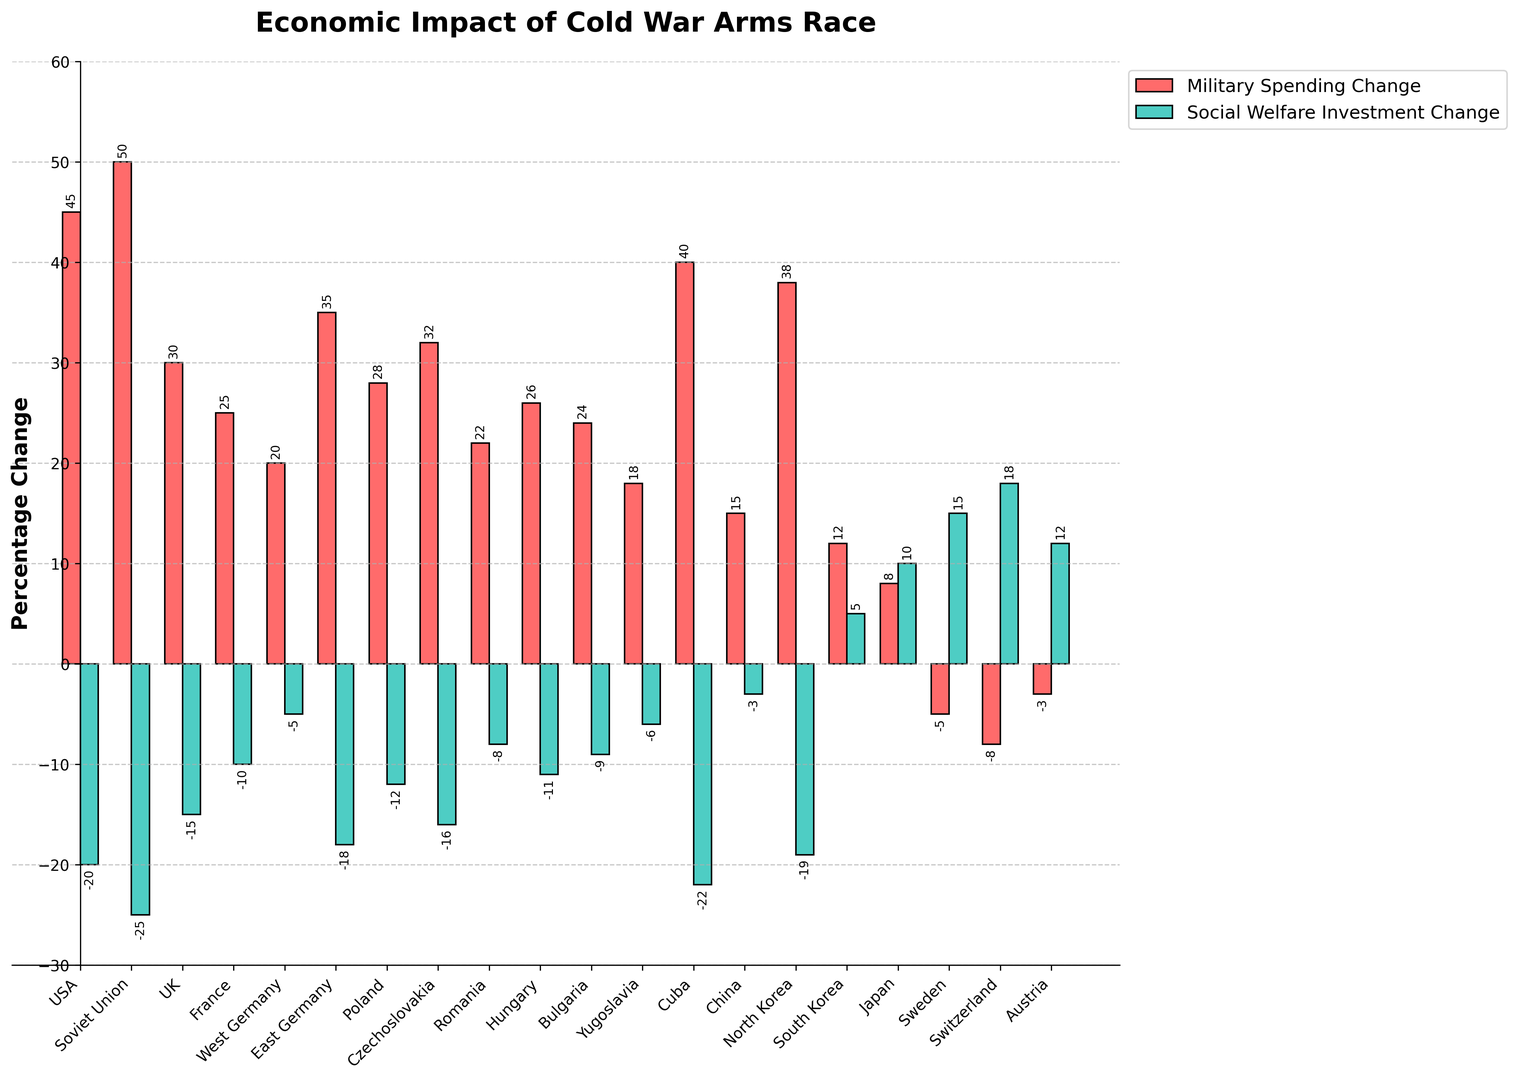Which country has the highest increase in military spending? The highest military spending increase can be seen by looking at the tallest red bar in the chart.
Answer: Soviet Union What is the difference between the military spending increase of the USA and the Soviet Union? The military spending increase for the USA is 45 and for the Soviet Union is 50. The difference is calculated as 50 - 45.
Answer: 5 Which country has a positive change in social welfare investments but a negative change in military spending? Countries with positive green bars (social welfare) and negative red bars (military spending) are considered. Based on this, we can visually see Sweden, Switzerland, and Austria meet this criterion.
Answer: Sweden, Switzerland, Austria What is the average change in social welfare investments for the countries with increased military spending? Calculate the sum of positive green bars for countries with positive red bars, divide by the number of such countries. The relevant countries: USA (-20), Soviet Union (-25), UK (-15), France (-10), West Germany (-5), East Germany (-18), Poland (-12), Czechoslovakia (-16), Romania (-8), Hungary (-11), Bulgaria (-9), Yugoslavia (-6), Cuba (-22), China (-3), North Korea (-19), South Korea (5), Japan (10). Sum = -165, Average = -165/17.
Answer: -9.71 Which country shows a positive change in both military spending and social welfare investments? Both bars for this country must be above the zero line. South Korea and Japan meet this condition.
Answer: South Korea, Japan Which country experienced the largest decrease in social welfare investments? Visually, the country with the lowest position and longest green bar below the zero line represents the largest decrease.
Answer: Cuba What is the total change in military spending for the European countries listed? Sum up the changes in military spending for the European countries: UK (30), France (25), West Germany (20), East Germany (35), Poland (28), Czechoslovakia (32), Romania (22), Hungary (26), Bulgaria (24), Yugoslavia (18). Sum = 260.
Answer: 260 Which country has the smallest decrease in social welfare investments? Visually, find the shortest green bar below the zero line. In this case, China has a change of -3, which is the smallest decrease.
Answer: China How many countries have a decrease in both military spending and social welfare investments? Count the countries with both red and green bars below the zero line. In this chart, there are three such countries: Sweden, Switzerland, and Austria.
Answer: 3 